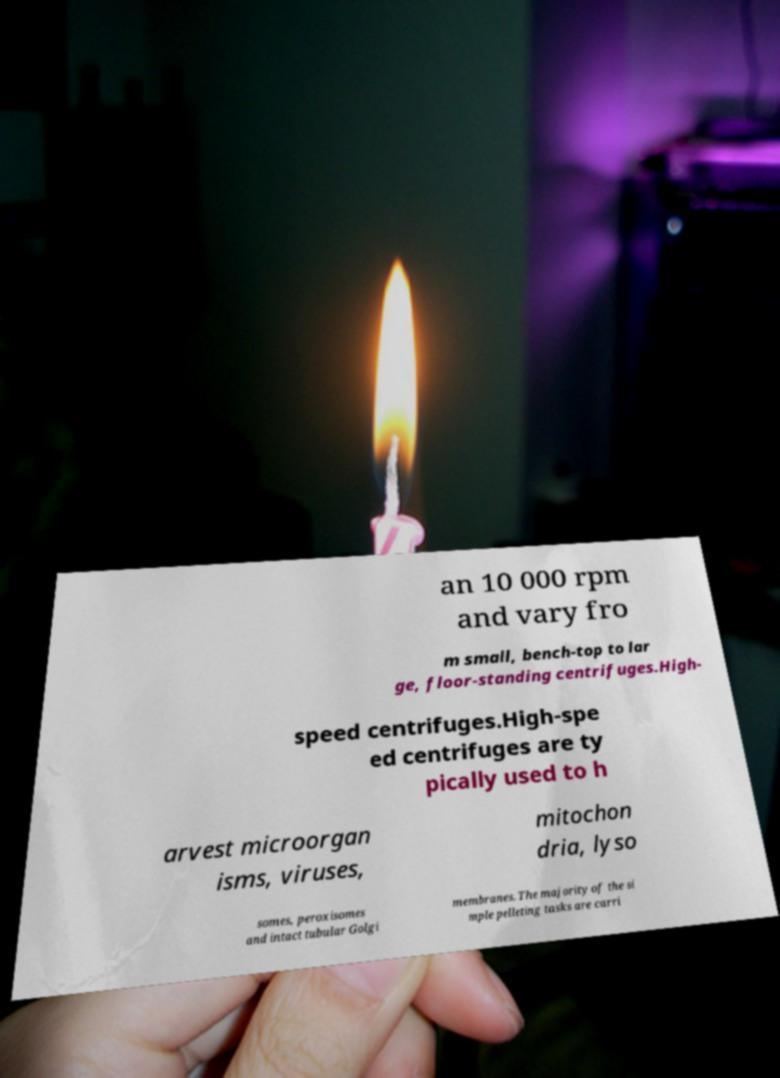Could you assist in decoding the text presented in this image and type it out clearly? an 10 000 rpm and vary fro m small, bench-top to lar ge, floor-standing centrifuges.High- speed centrifuges.High-spe ed centrifuges are ty pically used to h arvest microorgan isms, viruses, mitochon dria, lyso somes, peroxisomes and intact tubular Golgi membranes. The majority of the si mple pelleting tasks are carri 